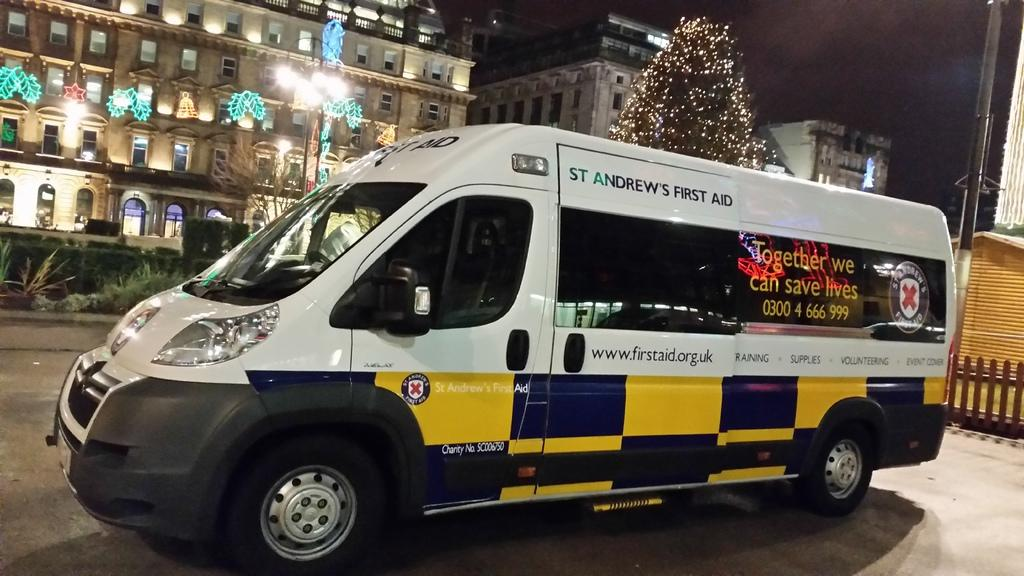Provide a one-sentence caption for the provided image. a st. andrews first aid vehicle with yellow and blue on the bottom. 